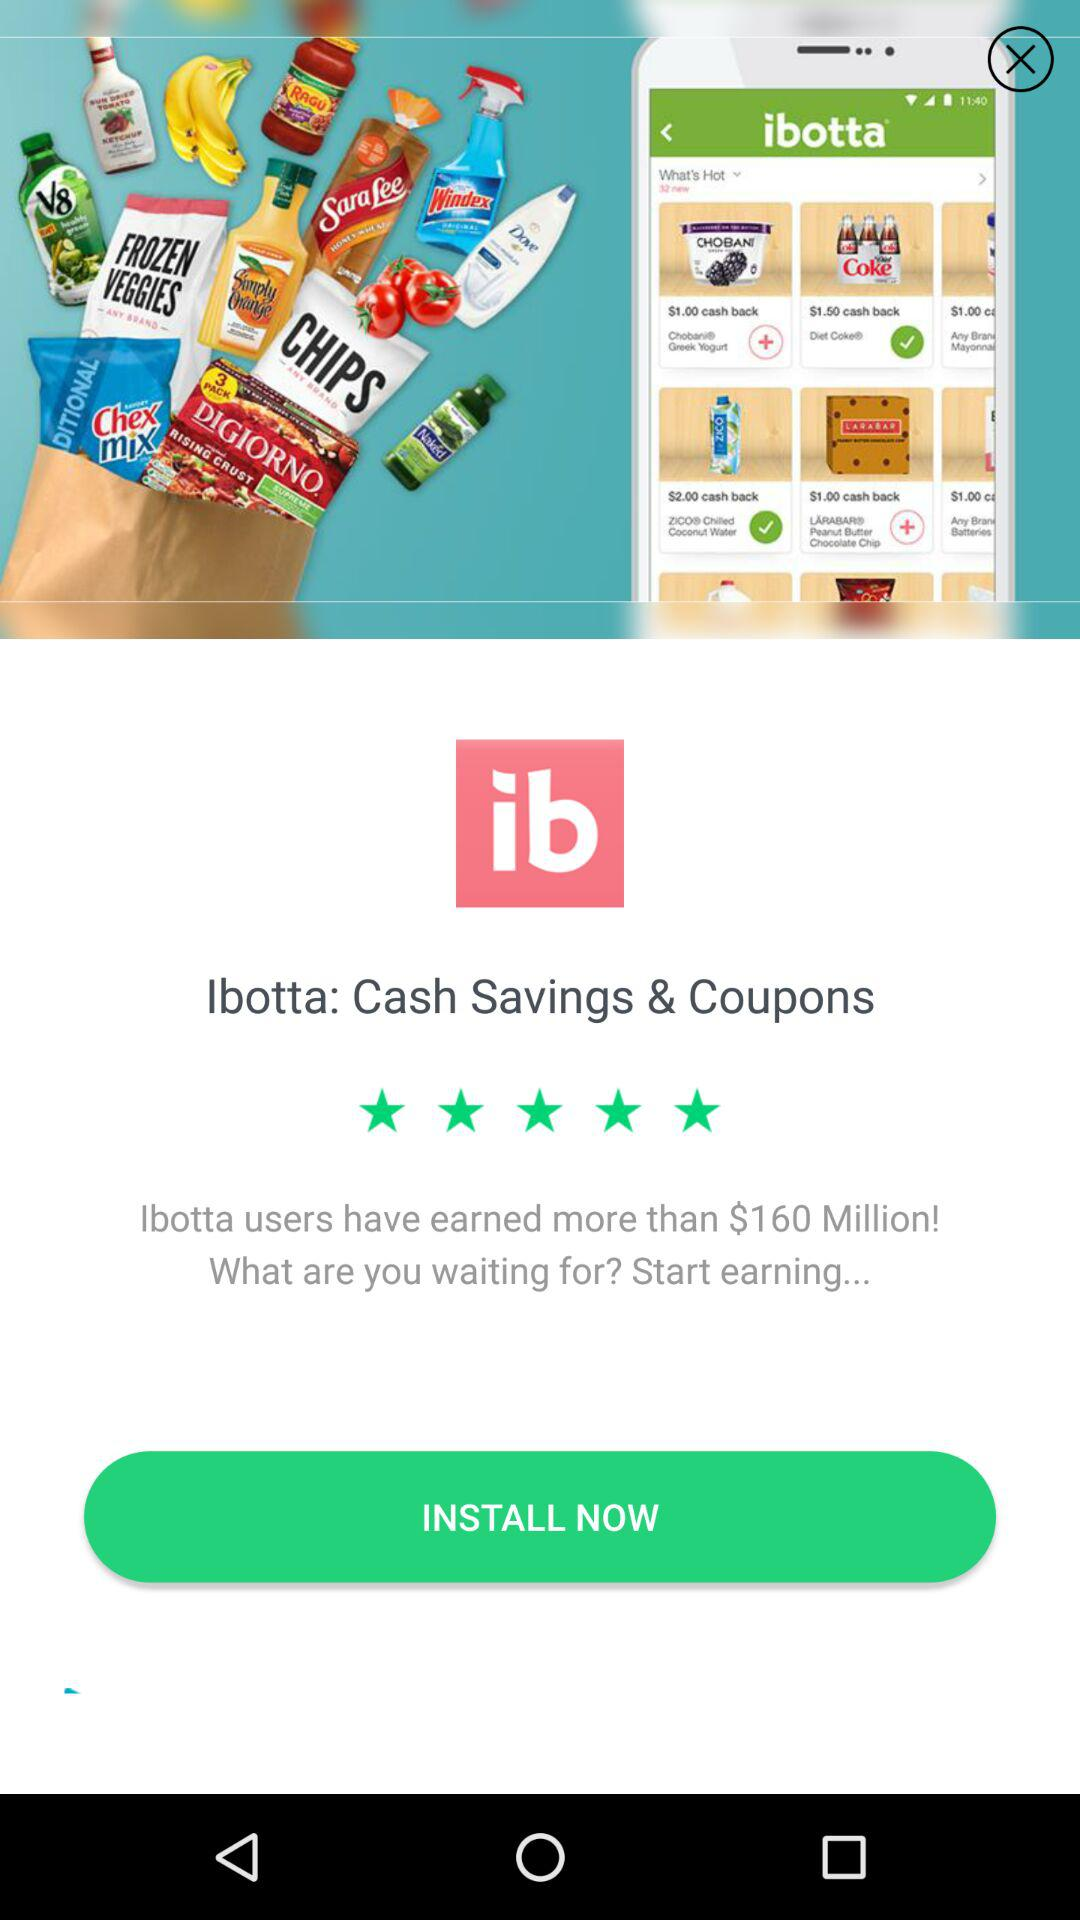How many dollars have Ibotta users earned?
Answer the question using a single word or phrase. $160 Million 